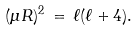<formula> <loc_0><loc_0><loc_500><loc_500>( \mu R ) ^ { 2 } \, = \, \ell ( \ell + 4 ) .</formula> 